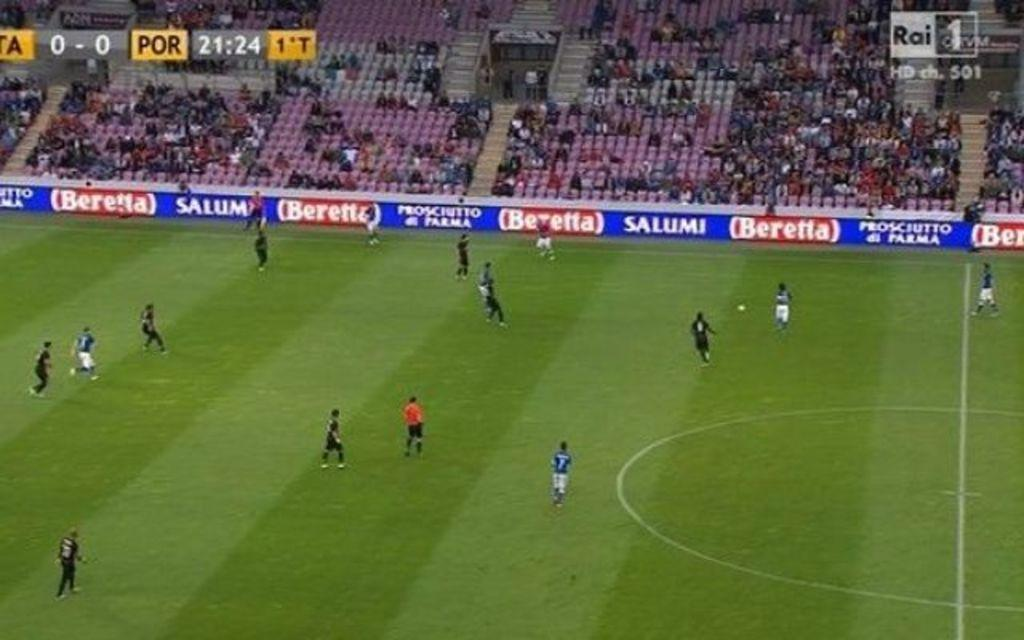<image>
Summarize the visual content of the image. a soccer game is being held on a field that is partially sponsored by Beretta 